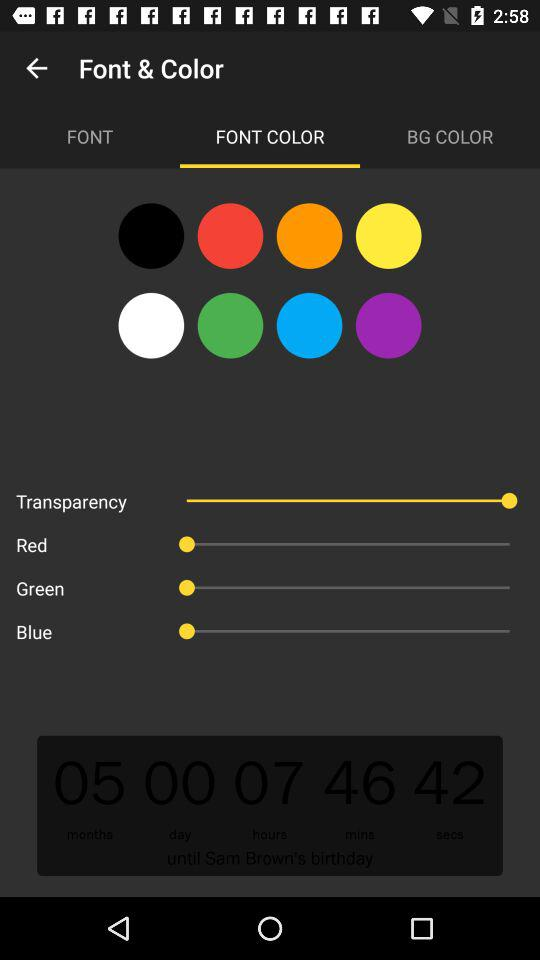How much time is left for Sam Brown's birthday party? The time left for Sam Brown's birthday party is 05 months, 00 days, 07 hours, 46 mins, and 42 secs. 